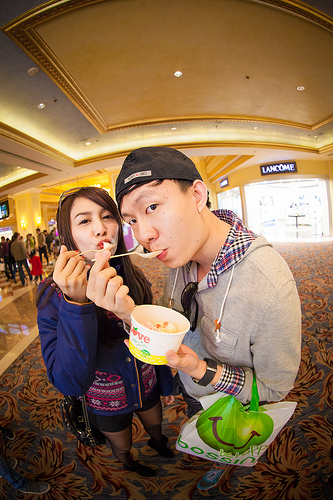<image>
Is the man to the left of the sign? No. The man is not to the left of the sign. From this viewpoint, they have a different horizontal relationship. Where is the man in relation to the woman? Is it under the woman? No. The man is not positioned under the woman. The vertical relationship between these objects is different. Is the man next to the girl? Yes. The man is positioned adjacent to the girl, located nearby in the same general area. 